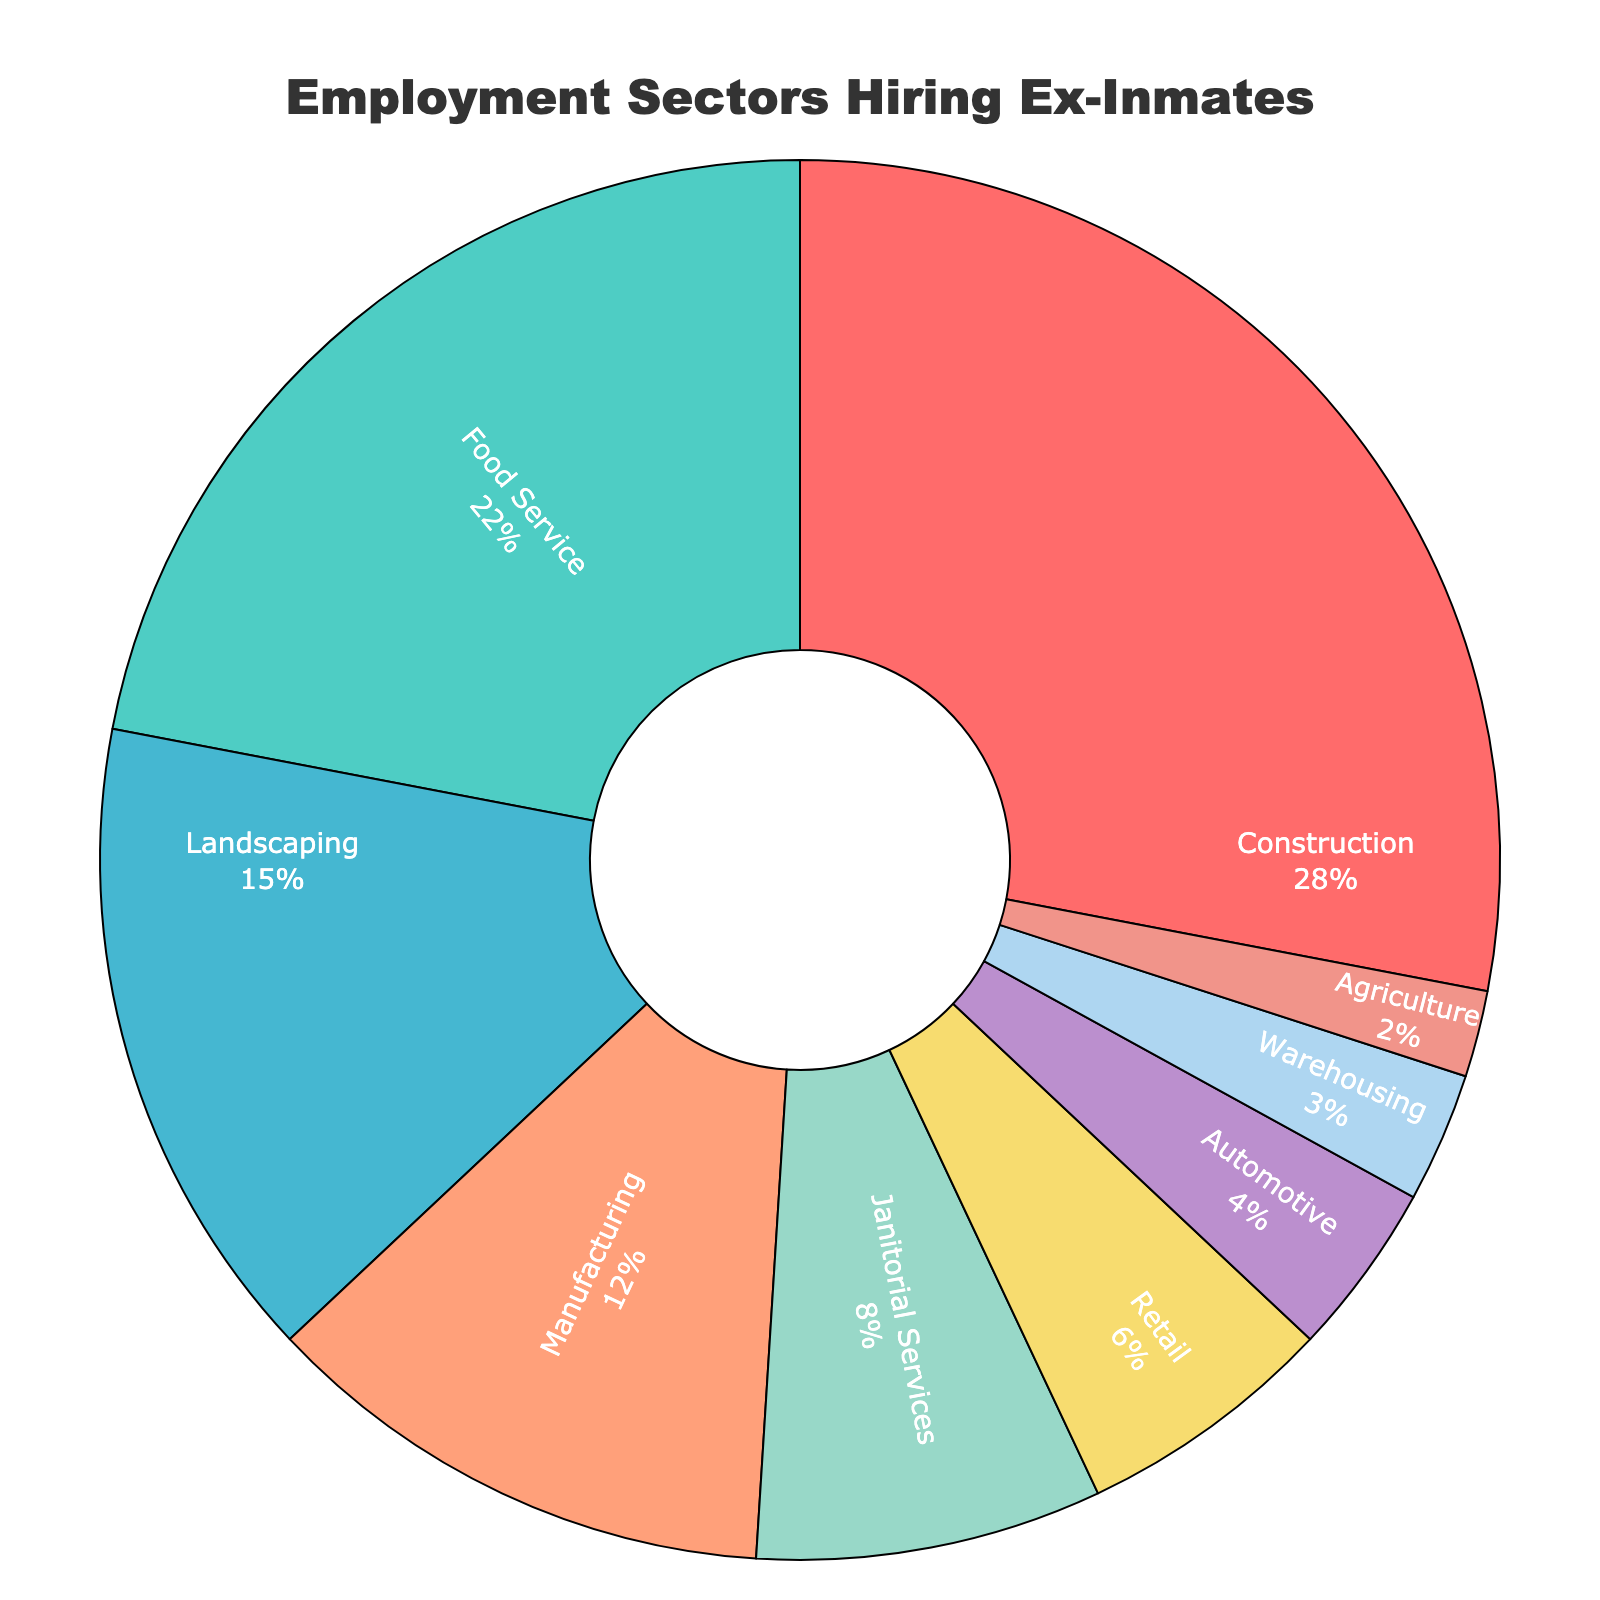What is the employment sector with the highest percentage of ex-inmates hired? The section of the pie chart with the largest proportion indicates the sector hiring the highest percentage of ex-inmates. According to the chart, "Construction" has the largest section.
Answer: Construction How many sectors combined account for more than 50% of the hiring? By summing the percentages starting from the largest, we find Construction (28%) + Food Service (22%) = 50%. Therefore, two sectors together account for more than 50%.
Answer: 2 Which sector hires fewer ex-inmates: Retail or Janitorial Services? By comparing the percentages from the chart, Retail hires 6%, whereas Janitorial Services hires 8%.
Answer: Retail What is the least hiring sector for ex-inmates? The smallest section of the pie chart represents the sector that hires the least ex-inmates. "Agriculture" has the smallest percentage in the chart.
Answer: Agriculture What is the combined percentage of ex-inmates hired in Automotive, Warehousing, and Agriculture sectors? Add the percentages of Automotive (4%), Warehousing (3%), and Agriculture (2%) sectors from the chart: 4% + 3% + 2% = 9%.
Answer: 9% How does the hiring percentage in Food Service compare to Manufacturing? The chart indicates Food Service hires 22% of ex-inmates, while Manufacturing hires 12%. Hence, Food Service hires 10% more ex-inmates compared to Manufacturing.
Answer: Food Service hires 10% more Which sector has a greater hiring percentage: Warehousing or Automotive? The chart shows that Automotive hires 4% and Warehousing hires 3%. Therefore, Automotive has a higher hiring percentage than Warehousing.
Answer: Automotive What are the two smallest sectors hiring ex-inmates and their combined percentage? The smallest sectors based on the chart are Agriculture (2%) and Warehousing (3%). Their combined percentage is 2% + 3% = 5%.
Answer: Agriculture and Warehousing, 5% If you remove the largest and smallest sectors, what is the new combined percentage for Janitorial Services, Retail, and Automotive? Removing the largest (Construction, 28%) and smallest (Agriculture, 2%) sectors: Sum percentages for Janitorial Services (8%), Retail (6%), and Automotive (4%): 8% + 6% + 4% = 18%.
Answer: 18% Which sectors combined result in exactly 50% hiring? By summing from the largest, Construction (28%) and Food Service (22%) equal 50% combined according to the chart.
Answer: Construction and Food Service 